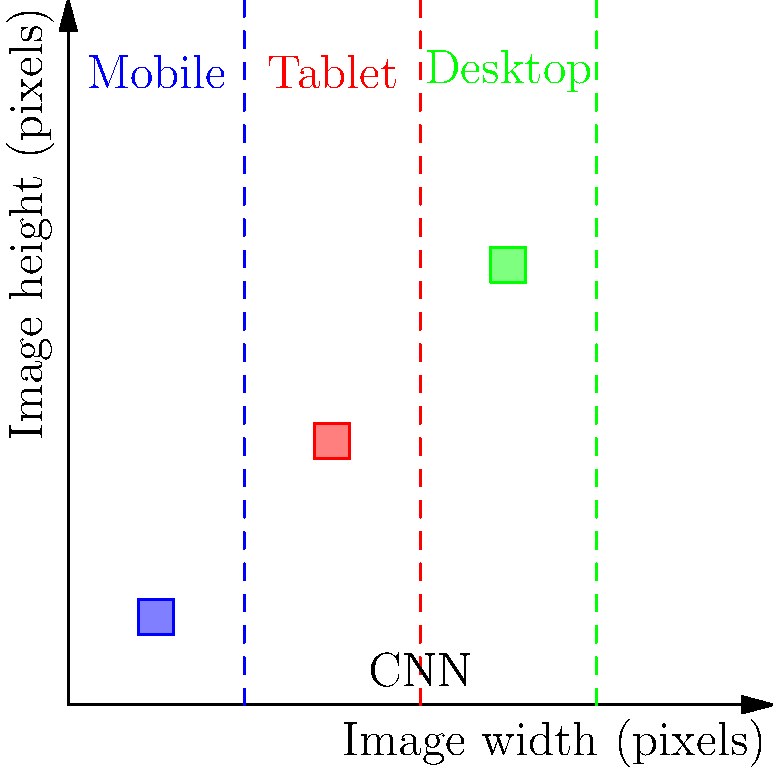In the context of using convolutional neural networks (CNNs) to detect and classify responsive design breakpoints in website screenshots, which of the following statements is most accurate regarding the implementation of this approach for a frontend developer? To understand the correct implementation of CNNs for detecting responsive design breakpoints, let's break down the process:

1. Data preparation:
   - Collect website screenshots at various resolutions
   - Label the images with corresponding breakpoints (e.g., mobile, tablet, desktop)

2. CNN architecture:
   - Input layer: Accept website screenshots as input
   - Convolutional layers: Extract features from the images
   - Pooling layers: Reduce spatial dimensions and computational complexity
   - Fully connected layers: Classify the extracted features into breakpoint categories

3. Training process:
   - Use labeled data to train the CNN
   - Optimize the network's parameters using backpropagation and gradient descent

4. Implementation considerations:
   - Use a pre-trained model (e.g., VGG, ResNet) and fine-tune it for breakpoint detection
   - Ensure the model can handle various image sizes and aspect ratios
   - Implement data augmentation techniques to improve model generalization

5. Integration with frontend development:
   - Use the trained model to analyze new website designs
   - Automate the process of identifying breakpoints in the CI/CD pipeline
   - Provide feedback to developers on potential responsive design issues

6. Performance optimization:
   - Use lightweight models or model compression techniques for faster inference
   - Implement caching mechanisms to store and reuse breakpoint predictions

7. Continuous improvement:
   - Regularly update the model with new training data
   - Monitor model performance and retrain as necessary

Given these steps, the most accurate statement for a frontend developer implementing this approach would focus on the integration of the CNN model with the existing development workflow and its practical application in improving responsive design.
Answer: Integrate the CNN model into the CI/CD pipeline to automate breakpoint detection and provide feedback on responsive design issues. 